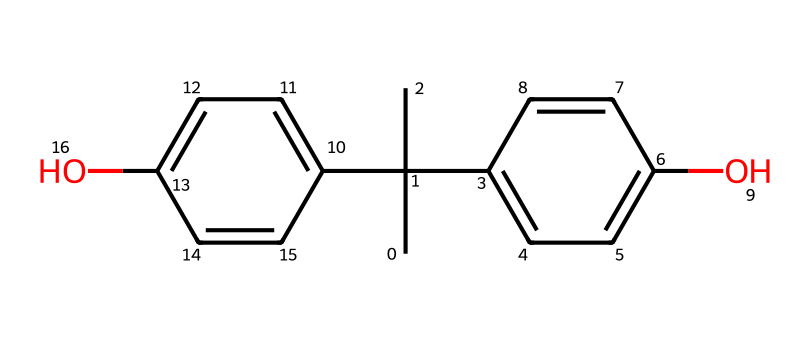What is the common name of this chemical? This chemical is known as bisphenol A. It is derived from its structure, which features two phenol rings connected by an isopropylidene group.
Answer: bisphenol A How many carbon atoms are there in bisphenol A? To find the number of carbon atoms, I analyze the SMILES representation, counting each "C". In the provided structure, there are 15 carbon atoms in total.
Answer: 15 How many hydroxyl (–OH) groups are present in this chemical? The SMILES notation indicates two "O" atoms, which correspond to the two hydroxyl groups linked to the phenolic rings. Therefore, there are two –OH groups present.
Answer: 2 What type of function groups are represented in bisphenol A? The functional groups in bisphenol A include hydroxyl groups (–OH) and the phenolic structure, indicating it is a phenol derivative.
Answer: hydroxyl groups Is bisphenol A considered harmful to wildlife? Due to its endocrine-disrupting properties and the potential to bioaccumulate, bisphenol A is associated with negative impacts on wildlife health and reproduction.
Answer: yes How many rings are present in the structure of bisphenol A? By examining the structure in the SMILES, I see that there are two distinct aromatic rings (phenolic). This gives a total of two rings present in bisphenol A.
Answer: 2 